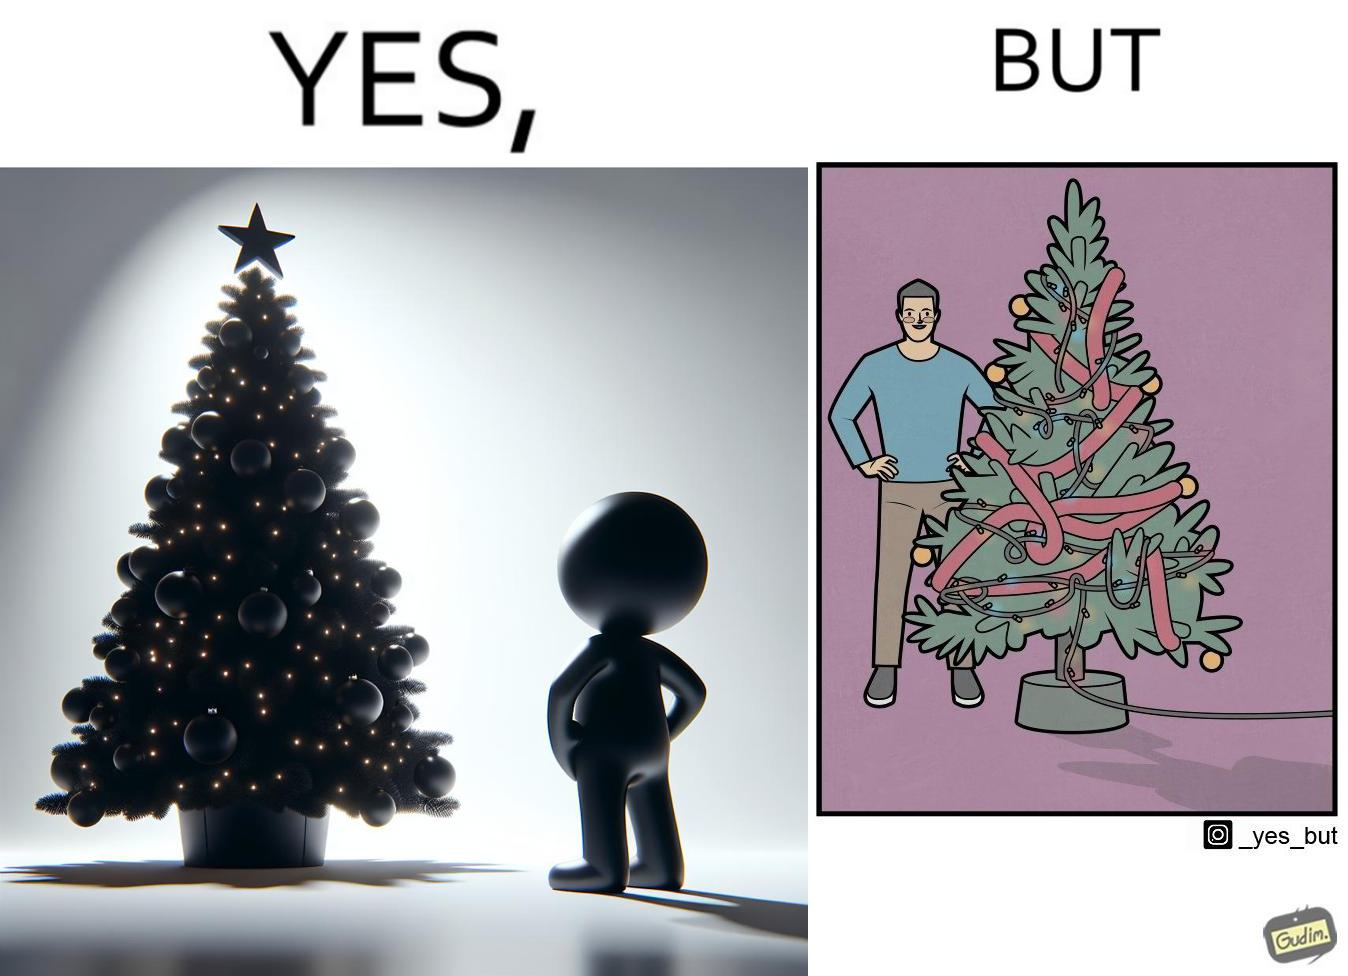Why is this image considered satirical? The image is ironic, because in the first image a person is seen watching his decorated X-mas tree but in the second image it is shown that the tree is looking beautiful not due to its natural beauty but the bulbs connected via power decorated over it 